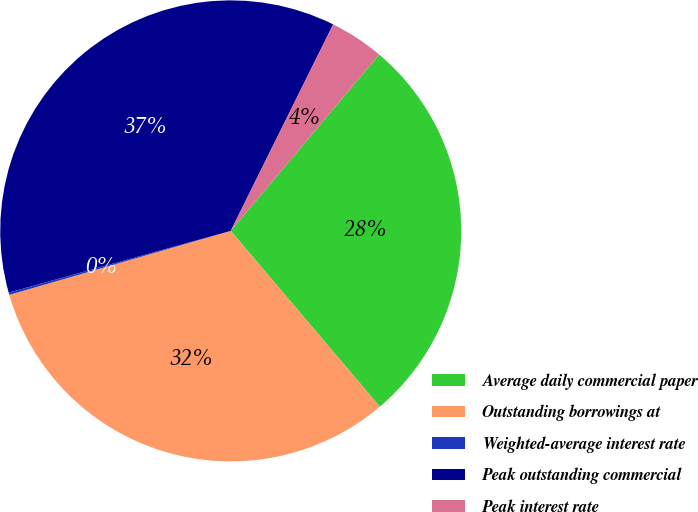Convert chart. <chart><loc_0><loc_0><loc_500><loc_500><pie_chart><fcel>Average daily commercial paper<fcel>Outstanding borrowings at<fcel>Weighted-average interest rate<fcel>Peak outstanding commercial<fcel>Peak interest rate<nl><fcel>27.67%<fcel>31.72%<fcel>0.16%<fcel>36.65%<fcel>3.81%<nl></chart> 